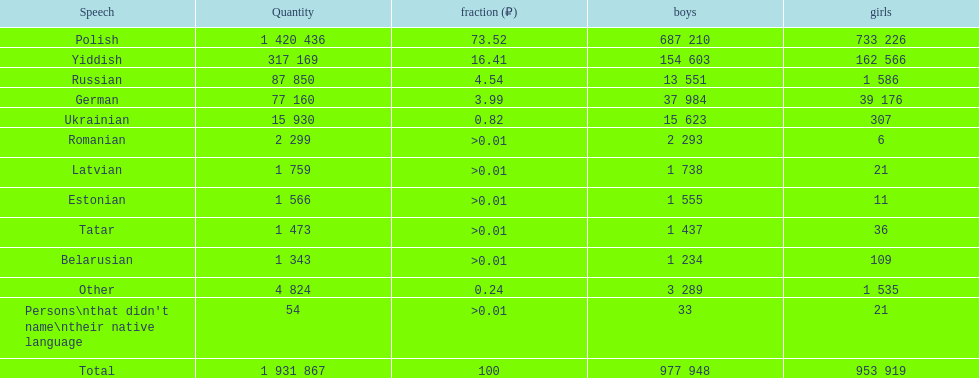The least amount of females Romanian. 